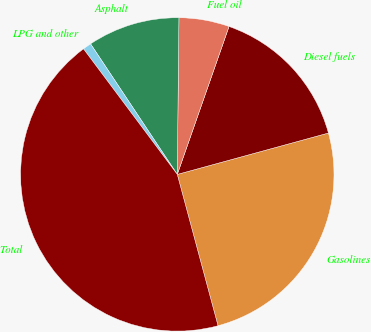Convert chart. <chart><loc_0><loc_0><loc_500><loc_500><pie_chart><fcel>Gasolines<fcel>Diesel fuels<fcel>Fuel oil<fcel>Asphalt<fcel>LPG and other<fcel>Total<nl><fcel>25.07%<fcel>15.39%<fcel>5.19%<fcel>9.5%<fcel>0.88%<fcel>43.98%<nl></chart> 